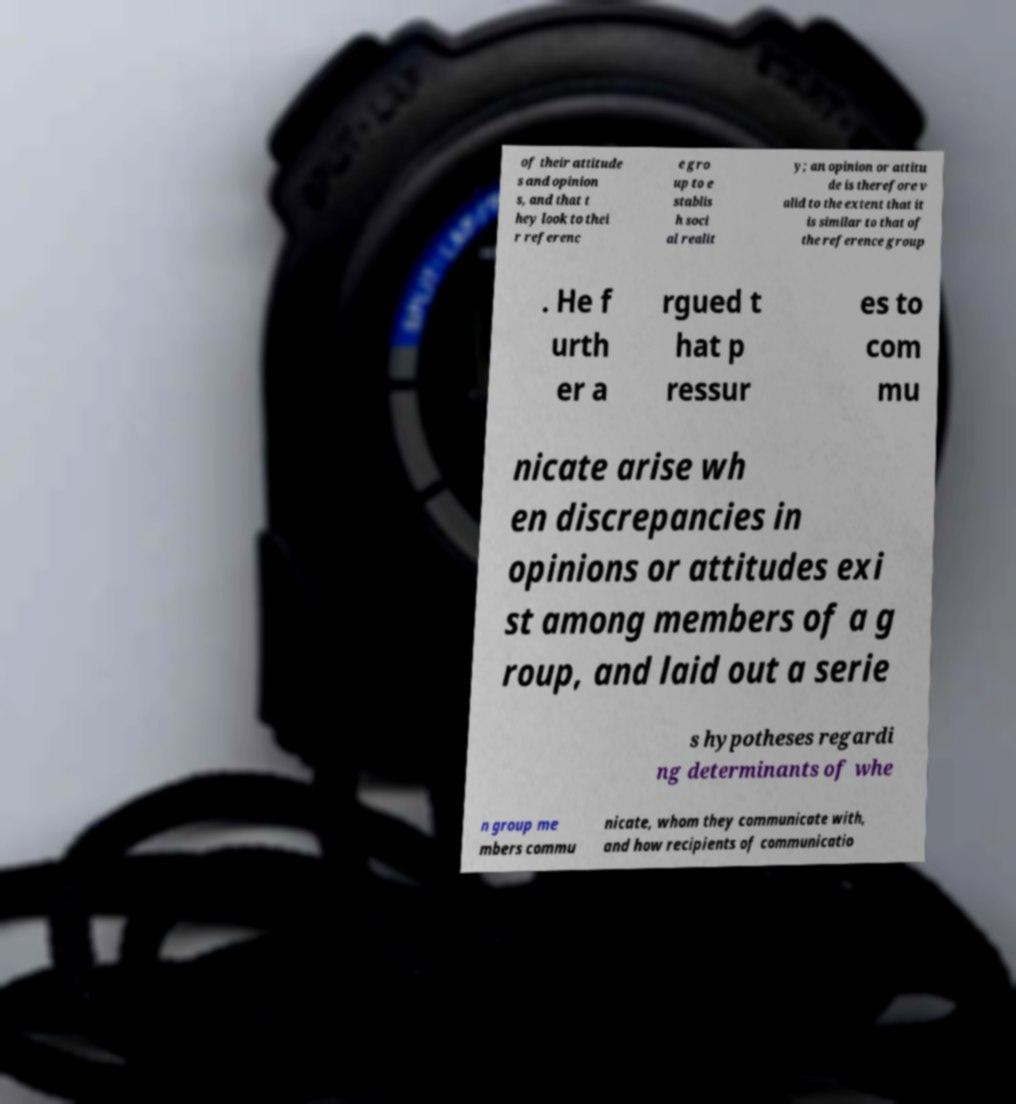For documentation purposes, I need the text within this image transcribed. Could you provide that? of their attitude s and opinion s, and that t hey look to thei r referenc e gro up to e stablis h soci al realit y; an opinion or attitu de is therefore v alid to the extent that it is similar to that of the reference group . He f urth er a rgued t hat p ressur es to com mu nicate arise wh en discrepancies in opinions or attitudes exi st among members of a g roup, and laid out a serie s hypotheses regardi ng determinants of whe n group me mbers commu nicate, whom they communicate with, and how recipients of communicatio 